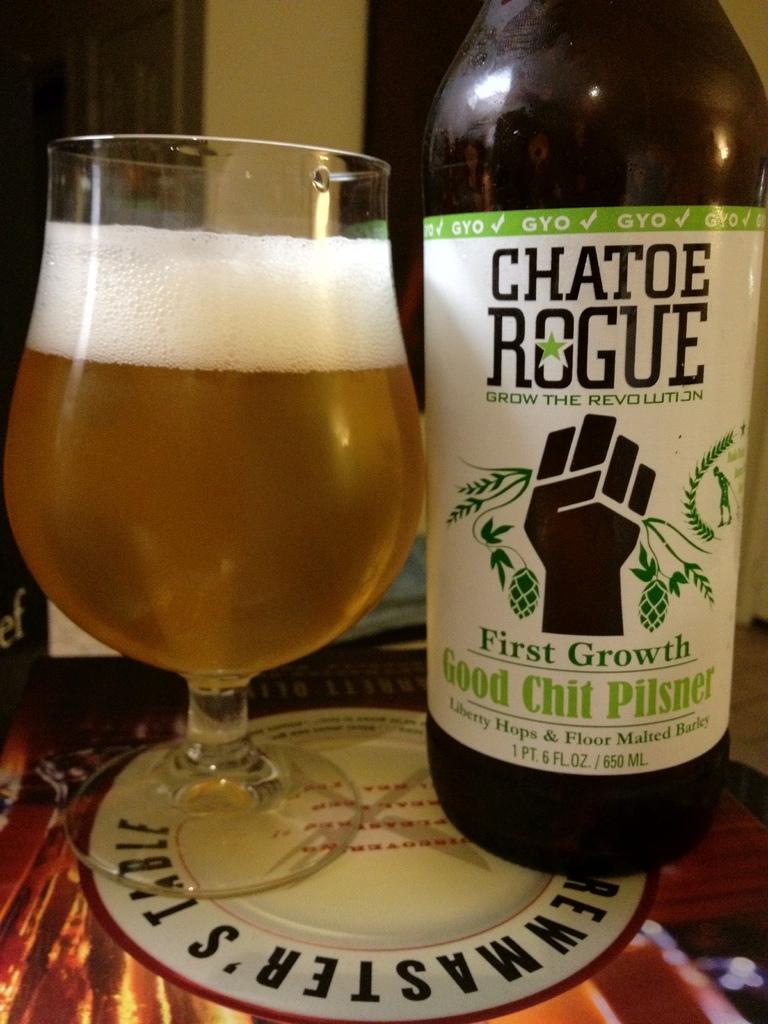What brand of pilsner is this?
Offer a terse response. Chatoe rogue. 